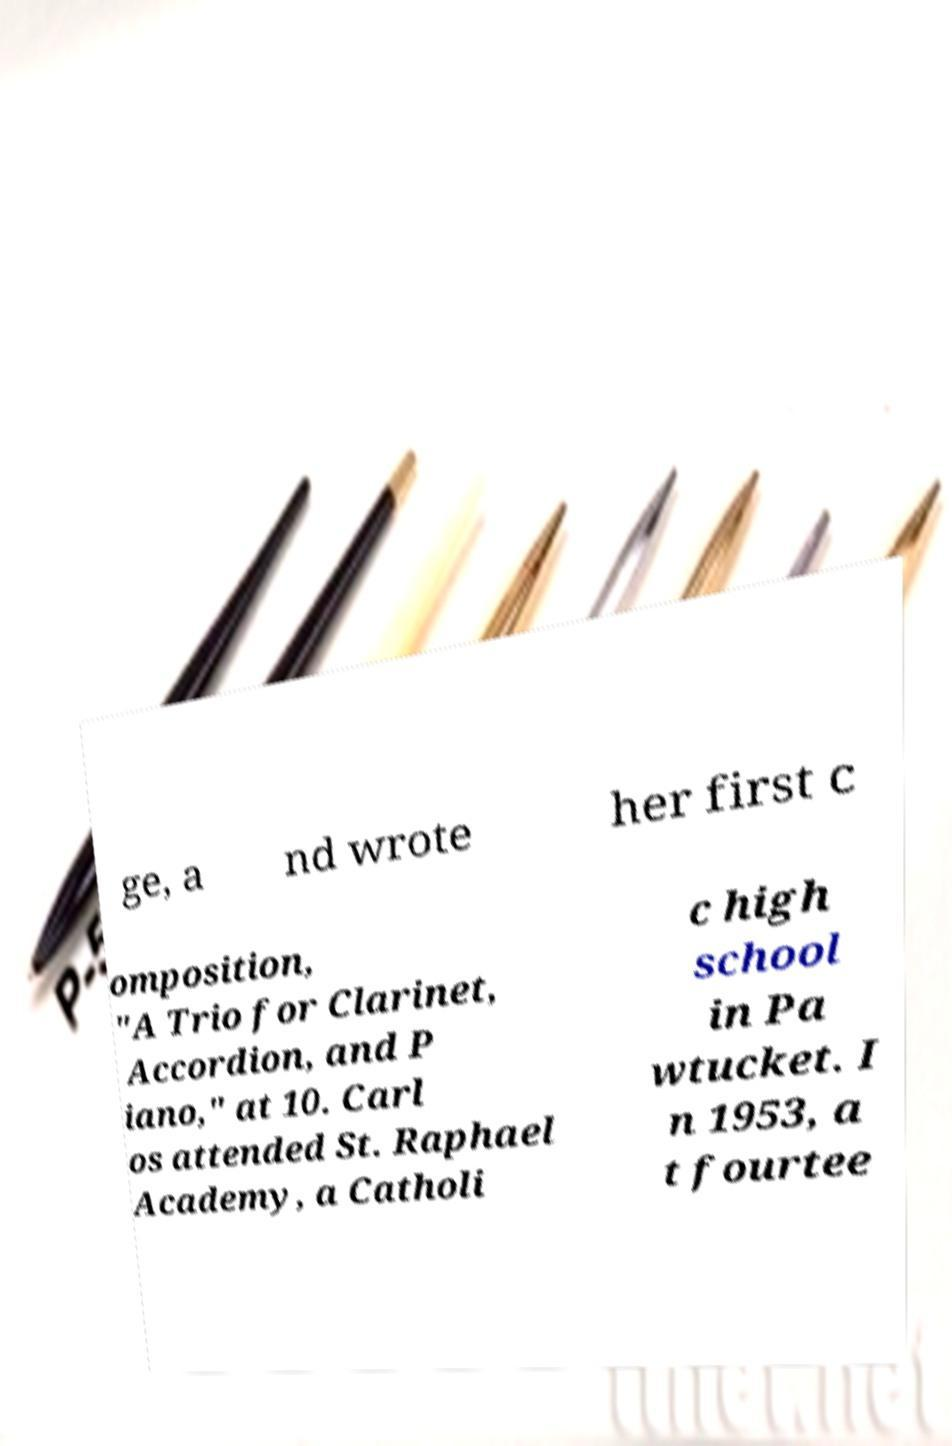Can you read and provide the text displayed in the image?This photo seems to have some interesting text. Can you extract and type it out for me? ge, a nd wrote her first c omposition, "A Trio for Clarinet, Accordion, and P iano," at 10. Carl os attended St. Raphael Academy, a Catholi c high school in Pa wtucket. I n 1953, a t fourtee 